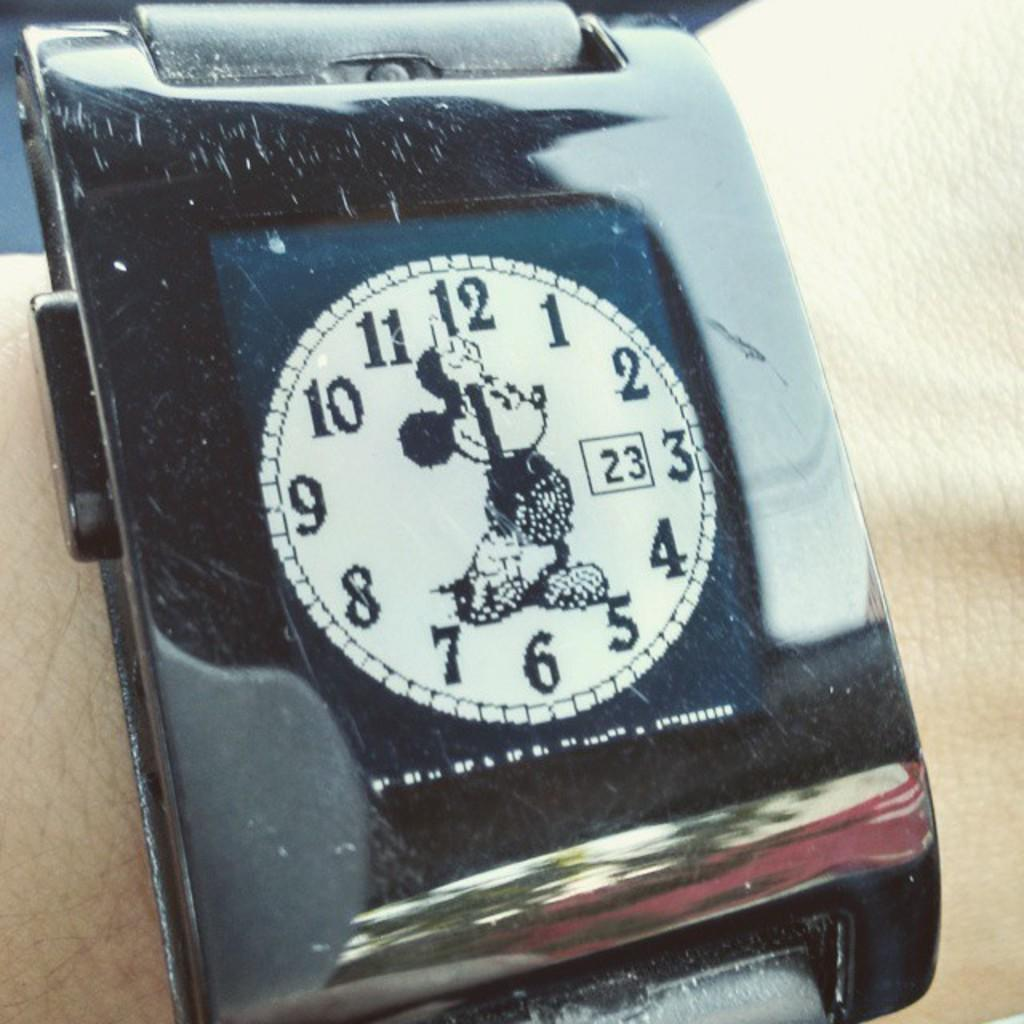Provide a one-sentence caption for the provided image. The digital Mickey Mouse watch shows the time is seven o'clock on the 23rd. 